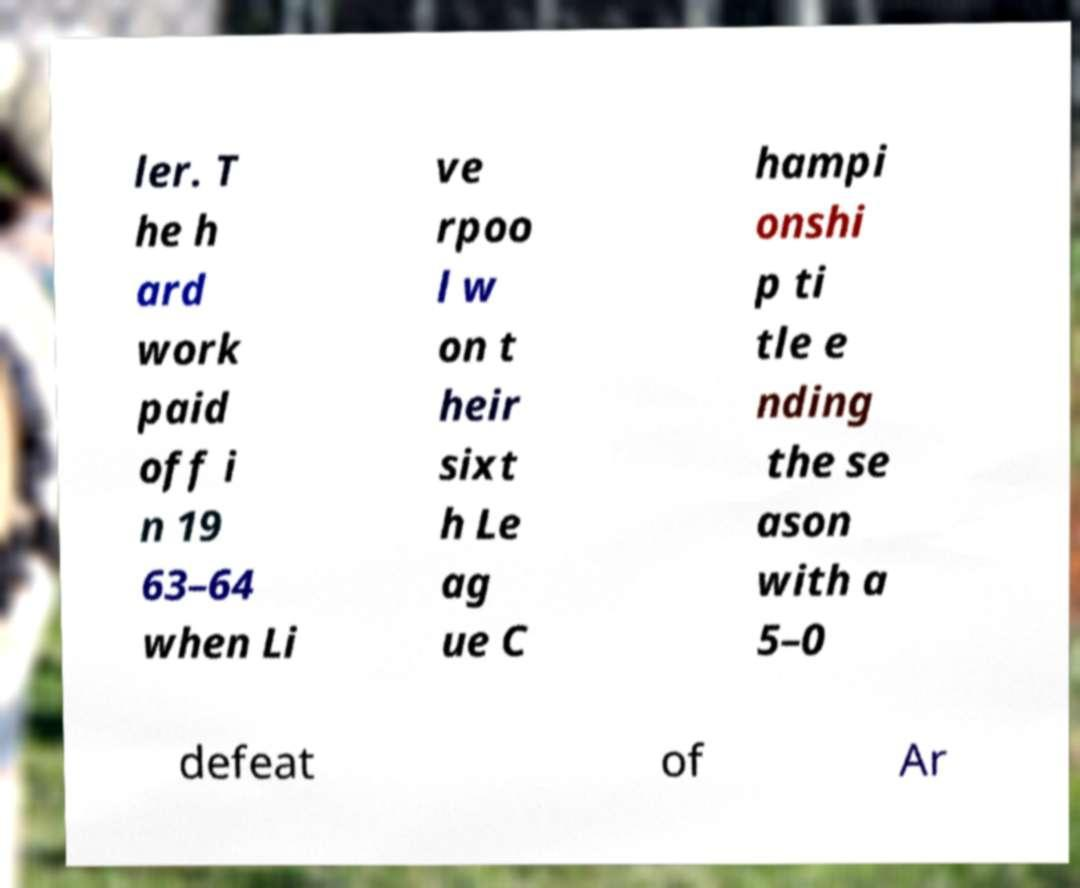Please read and relay the text visible in this image. What does it say? ler. T he h ard work paid off i n 19 63–64 when Li ve rpoo l w on t heir sixt h Le ag ue C hampi onshi p ti tle e nding the se ason with a 5–0 defeat of Ar 